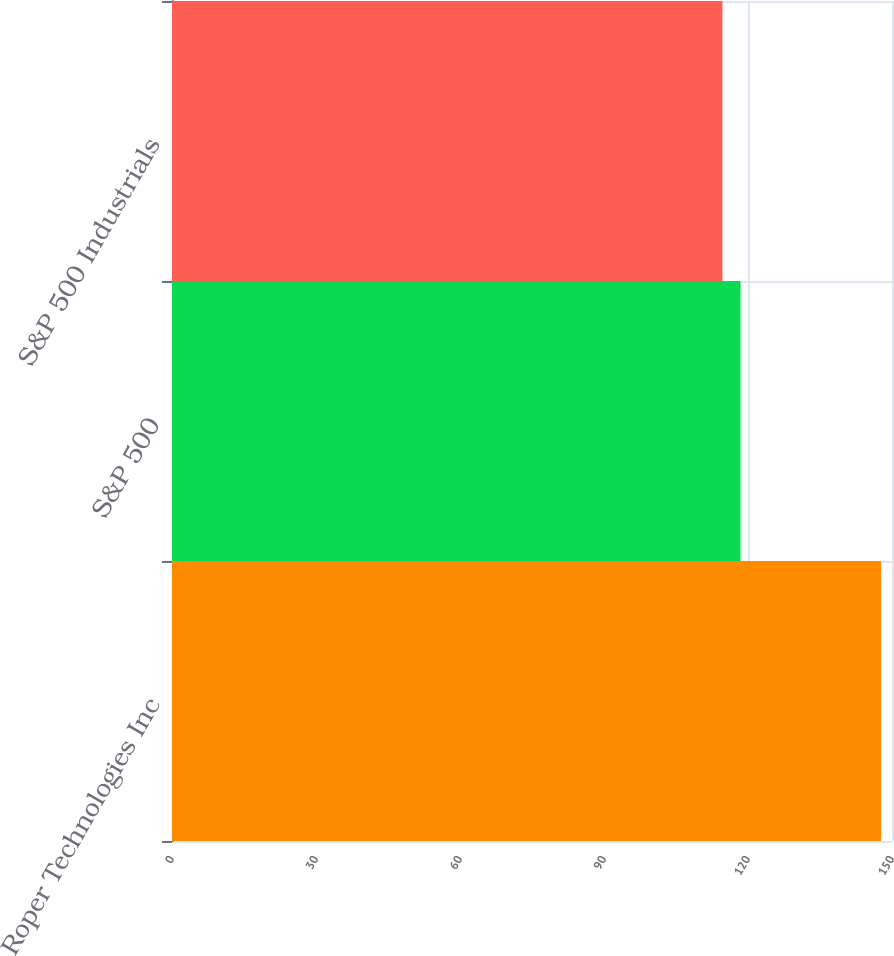<chart> <loc_0><loc_0><loc_500><loc_500><bar_chart><fcel>Roper Technologies Inc<fcel>S&P 500<fcel>S&P 500 Industrials<nl><fcel>147.73<fcel>118.45<fcel>114.67<nl></chart> 